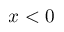<formula> <loc_0><loc_0><loc_500><loc_500>x < 0</formula> 